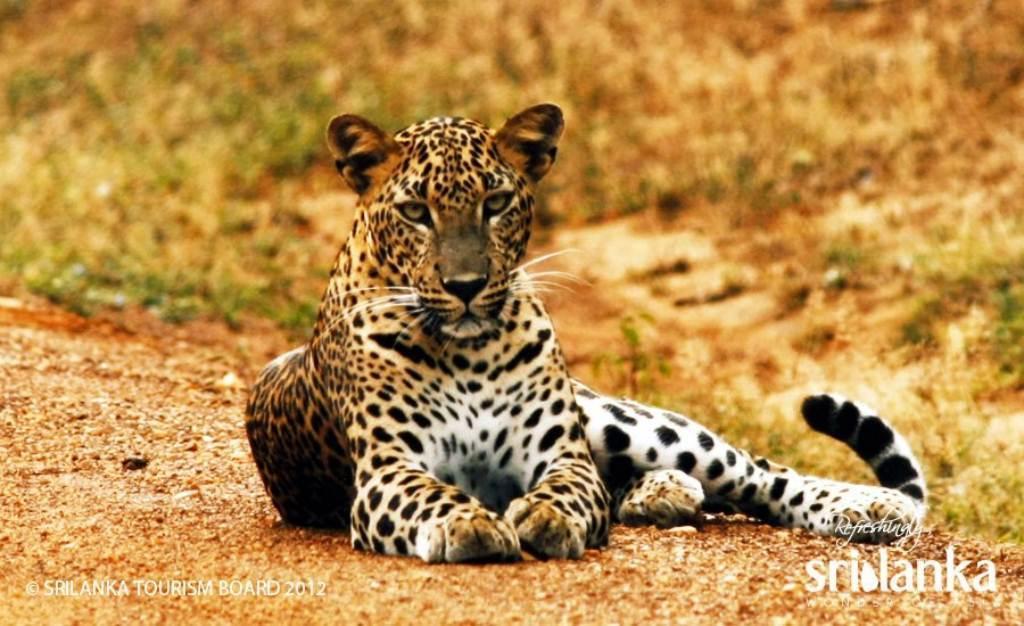Could you give a brief overview of what you see in this image? In this picture we can see tiger sitting on the surface. In the background of the image it is blurry. At the bottom of the image we can see text. 